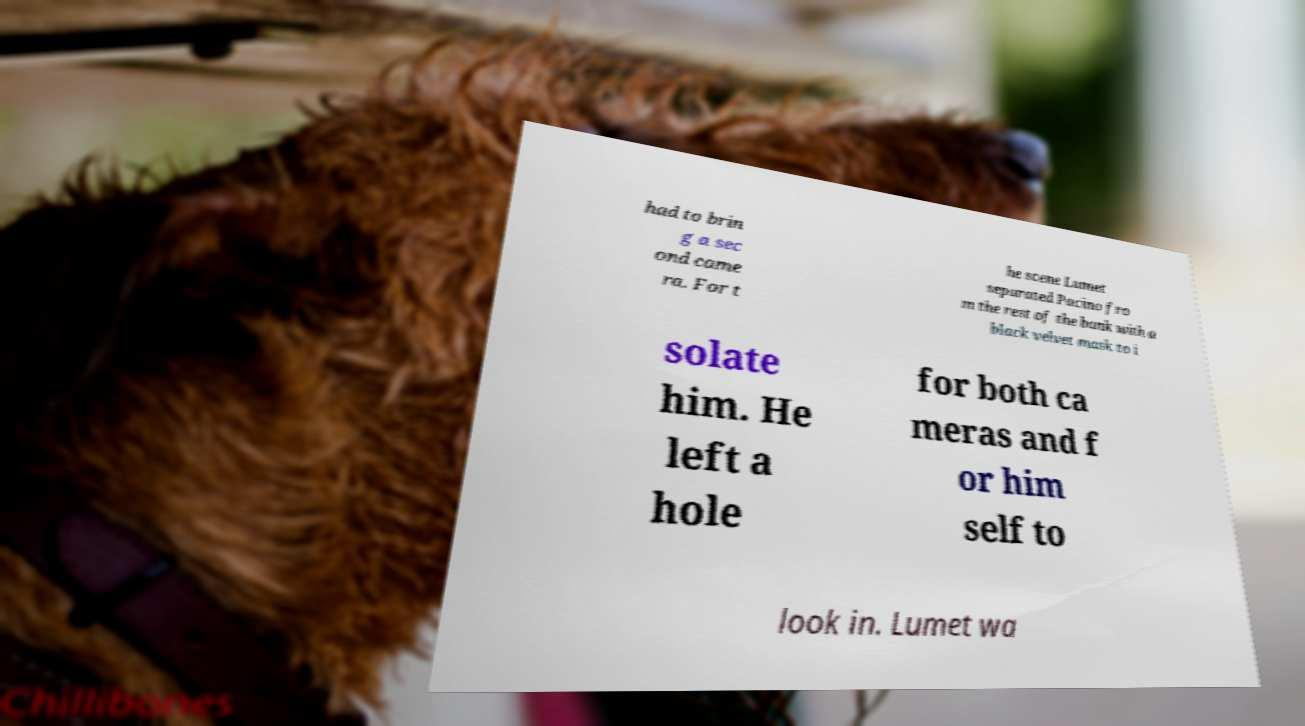Could you extract and type out the text from this image? had to brin g a sec ond came ra. For t he scene Lumet separated Pacino fro m the rest of the bank with a black velvet mask to i solate him. He left a hole for both ca meras and f or him self to look in. Lumet wa 